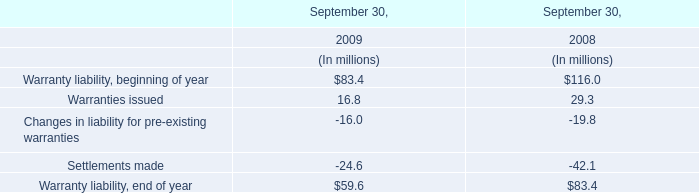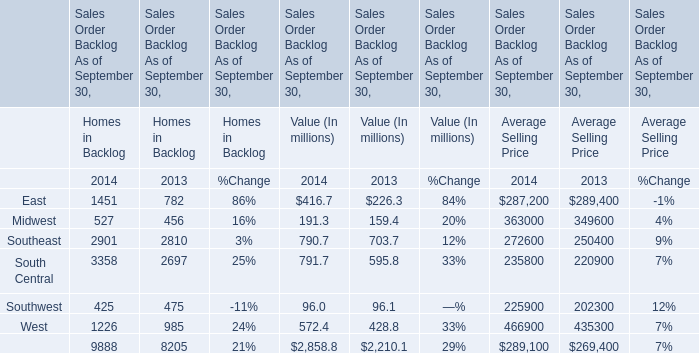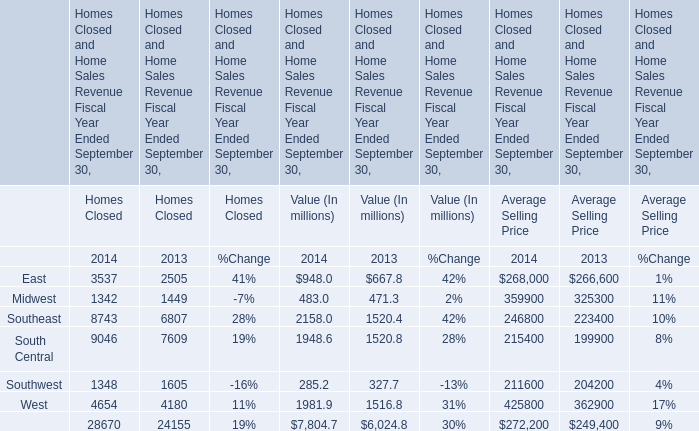What is the growing rate of Southeast for Value (In millions) in the years with the least Southwest for Value (In millions)? 
Computations: ((790.7 - 703.7) / 703.7)
Answer: 0.12363. 